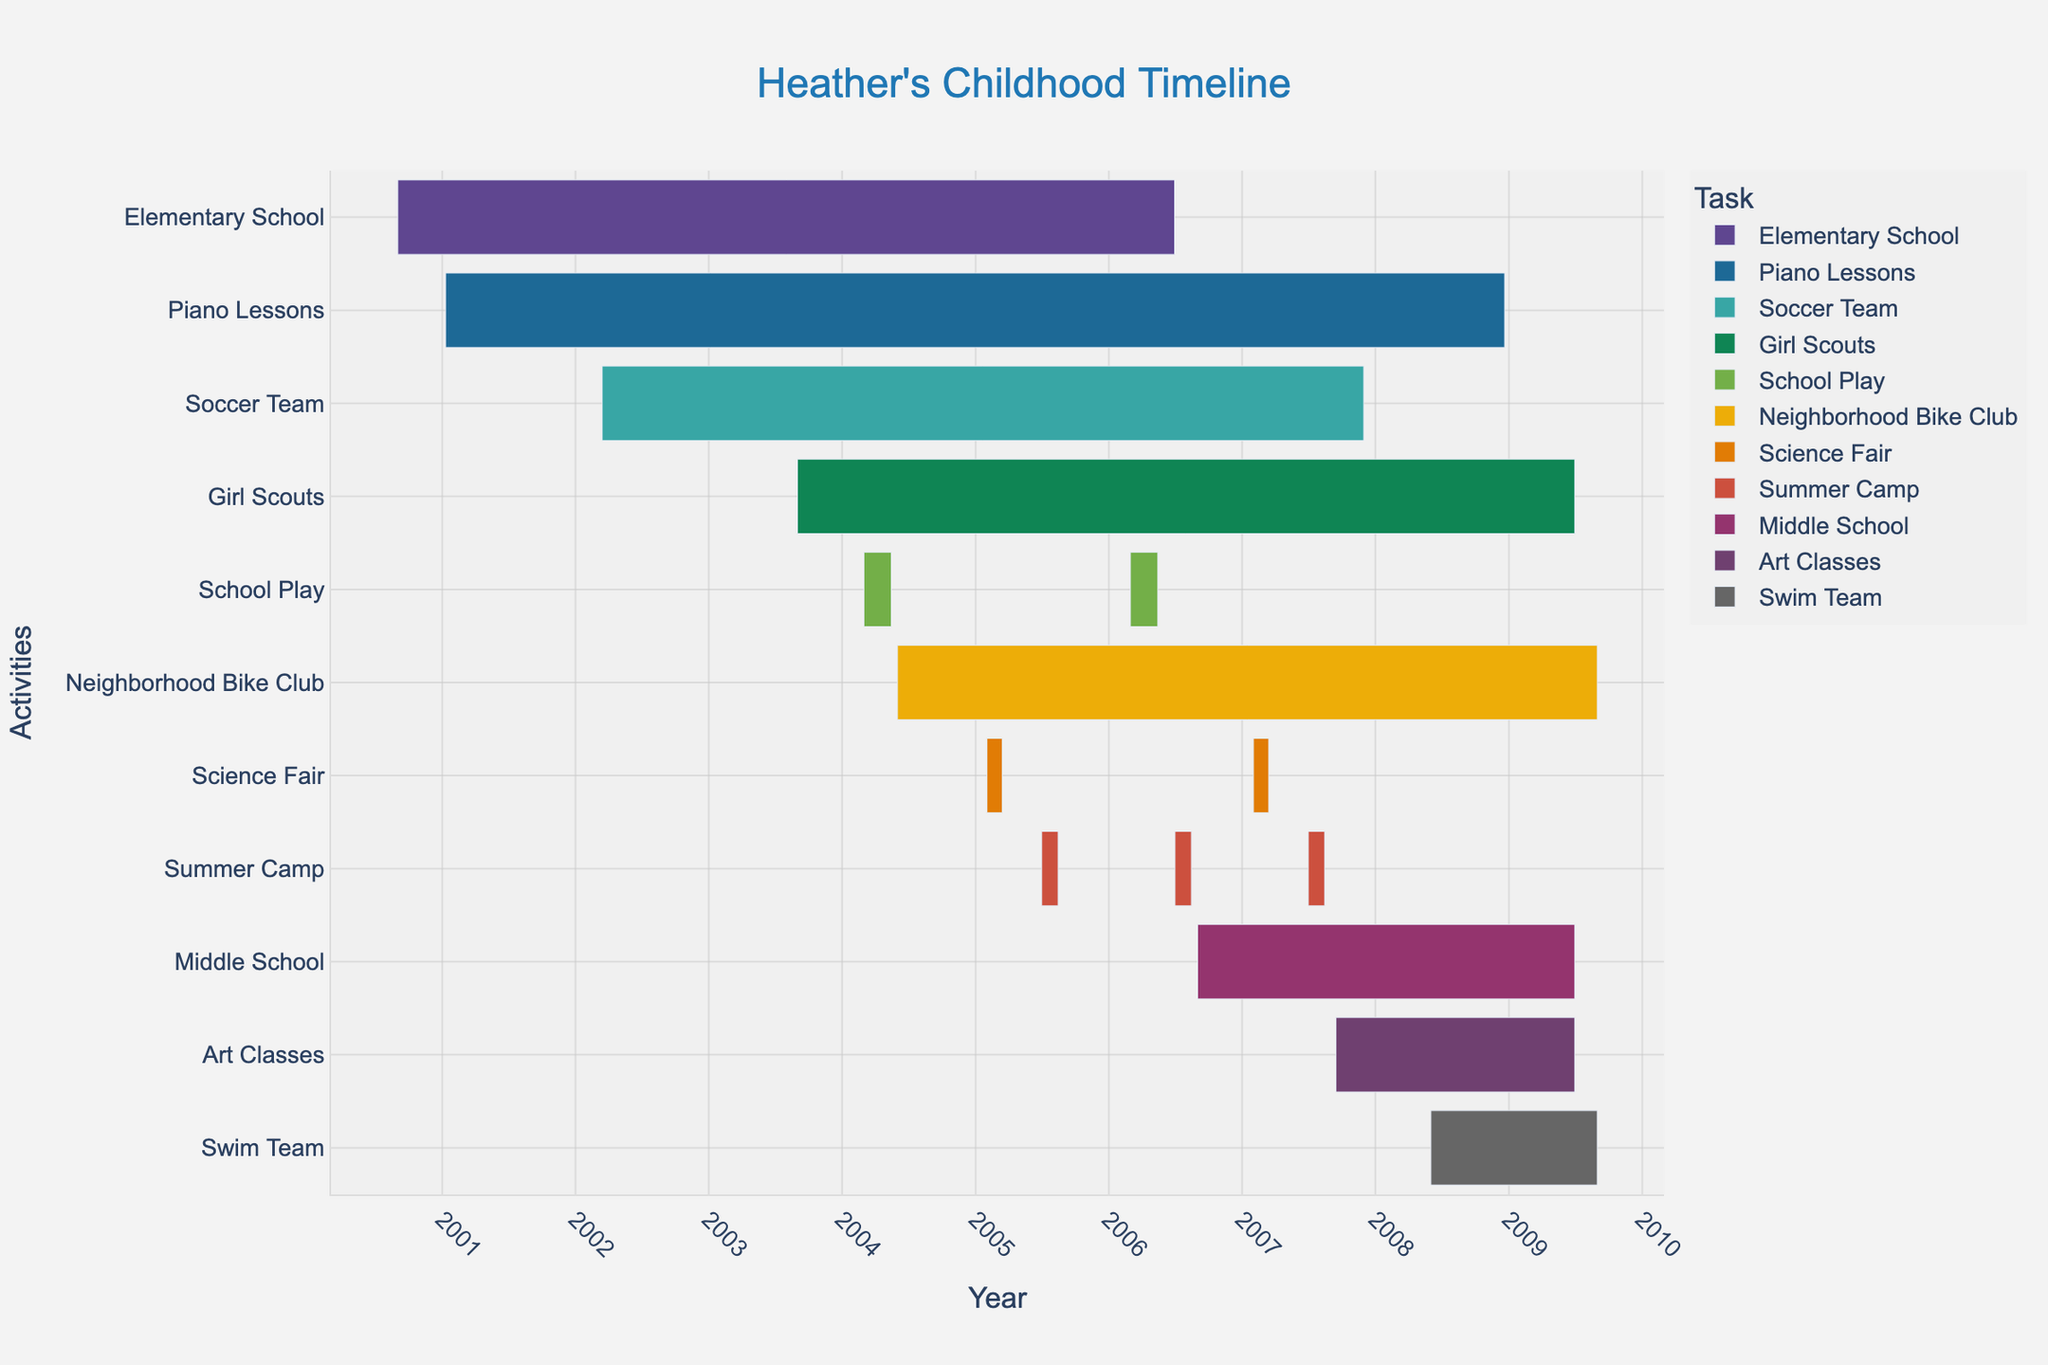What's the title of the chart? The title is located at the top center of the chart. It is an element that directly describes the overall content of the figure.
Answer: Heather's Childhood Timeline What are the start and end dates of Heather's Elementary School? Look at the Gantt chart and find the bar labeled "Elementary School." Check the start and end dates specified on the chart.
Answer: September 1, 2000, to June 30, 2006 Which activity lasted the longest during Heather's childhood? Compare the duration of all the different activities represented by the bars. The longest bar represents the activity that lasted the longest.
Answer: Elementary School Which activity overlaps with Heather's participation in the Soccer Team? Look for the timeframe when "Soccer Team" was active and identify any other bars (activities) that intersect with that period.
Answer: Elementary School How many times did Heather participate in the School Play? Count the number of bars labeled "School Play" on the chart. Each bar represents one instance of the activity.
Answer: Twice During which years did Heather attend the Summer Camp? Identify the bars labeled "Summer Camp." Look at the start and end dates for these bars.
Answer: 2005, 2006, 2007 Between Piano Lessons and Art Classes, which one started first and which ended later? Look at the bars for "Piano Lessons" and "Art Classes." Check the start date of each to see which one started first and the end date of each to see which ended later.
Answer: Piano Lessons started first, Art Classes ended later How many different activities did Heather participate in during her time in Middle School? Find the "Middle School" bar and check for any bars that overlap with it, indicating activities concurrent with her middle school years. Count those overlapping activities.
Answer: Five What was the shortest activity Heather participated in, and how long did it last? Compare the lengths of all bars to find the shortest one. Then, refer to its start and end dates to calculate the duration.
Answer: Each Science Fair, one lasted 1.5 months Which two activities did Heather start in the same year? Look for bars that have the same start year. Check their labels and confirm their start dates to verify.
Answer: Soccer Team and Piano Lessons in 2002 